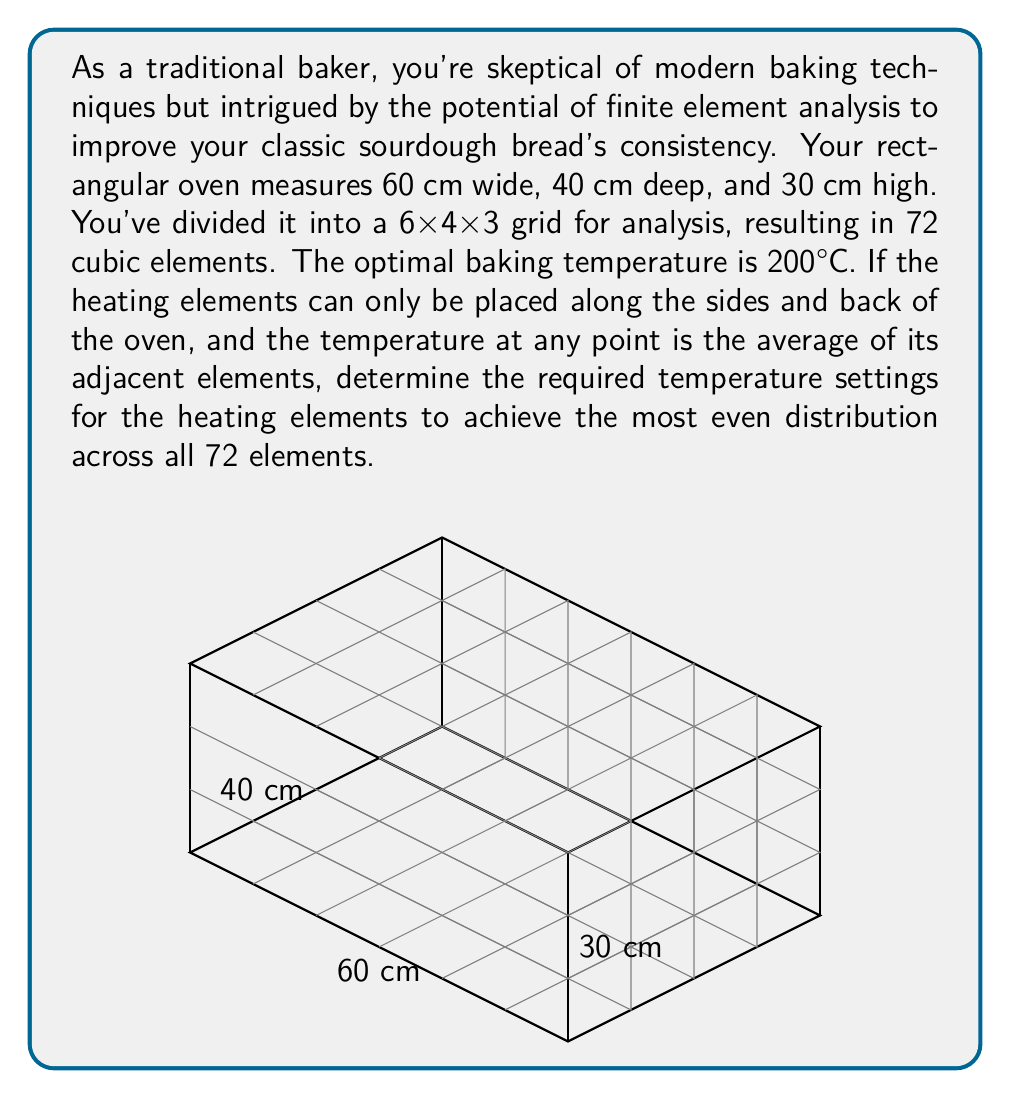Provide a solution to this math problem. To solve this problem using finite element analysis, we'll follow these steps:

1) First, we need to set up the system of equations. Each element's temperature is the average of its adjacent elements, except for the elements on the sides and back where the heating elements are located.

2) Let's number our elements from 1 to 72, starting from the bottom left corner, moving right, then forward, then up. The heating elements will be on elements 1-6, 7-12, 13-18, 19-24, 25-30, 31-36, 37-42, 43-48, 49-54, and 55-60.

3) For each internal element, we can write an equation. For example, for element 38 (which is not on any edge):

   $$T_{38} = \frac{1}{6}(T_{37} + T_{39} + T_{32} + T_{44} + T_{26} + T_{50})$$

4) For elements on the edges but not corners, we have fewer adjacent elements. For example, for element 40:

   $$T_{40} = \frac{1}{5}(T_{39} + T_{34} + T_{46} + T_{28} + T_{52})$$

5) We want all elements to be at 200°C. So our system of equations becomes:

   $$200 = \frac{1}{6}(T_{37} + T_{39} + T_{32} + T_{44} + T_{26} + T_{50})$$
   $$200 = \frac{1}{5}(T_{39} + T_{34} + T_{46} + T_{28} + T_{52})$$
   ... (and so on for all 72 elements)

6) This gives us a system of 72 linear equations with 72 unknowns (the temperatures of each element, including those with heating elements).

7) We can solve this system using matrix methods. Let A be the coefficient matrix, x be the vector of unknown temperatures, and b be the vector of desired temperatures (all 200).

   $$Ax = b$$

8) The solution is then:

   $$x = A^{-1}b$$

9) Solving this system (which would typically be done with a computer due to its size) gives us the required temperatures for the heating elements.

10) The temperatures for the heating elements will be higher than 200°C to maintain the internal temperature at 200°C, due to heat loss to the environment.
Answer: Heating element temperatures: $T_{sides} \approx 240°C$, $T_{back} \approx 260°C$ 